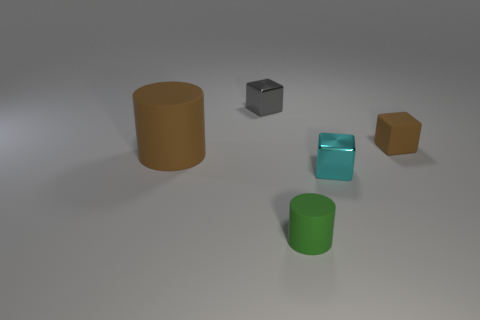Add 5 brown cubes. How many objects exist? 10 Subtract all shiny cubes. How many cubes are left? 1 Subtract all cyan cubes. How many cubes are left? 2 Subtract 1 cubes. How many cubes are left? 2 Subtract all blocks. How many objects are left? 2 Subtract all gray cubes. How many green cylinders are left? 1 Subtract all tiny red shiny cylinders. Subtract all tiny brown rubber blocks. How many objects are left? 4 Add 5 large brown matte cylinders. How many large brown matte cylinders are left? 6 Add 5 tiny yellow metal cylinders. How many tiny yellow metal cylinders exist? 5 Subtract 1 green cylinders. How many objects are left? 4 